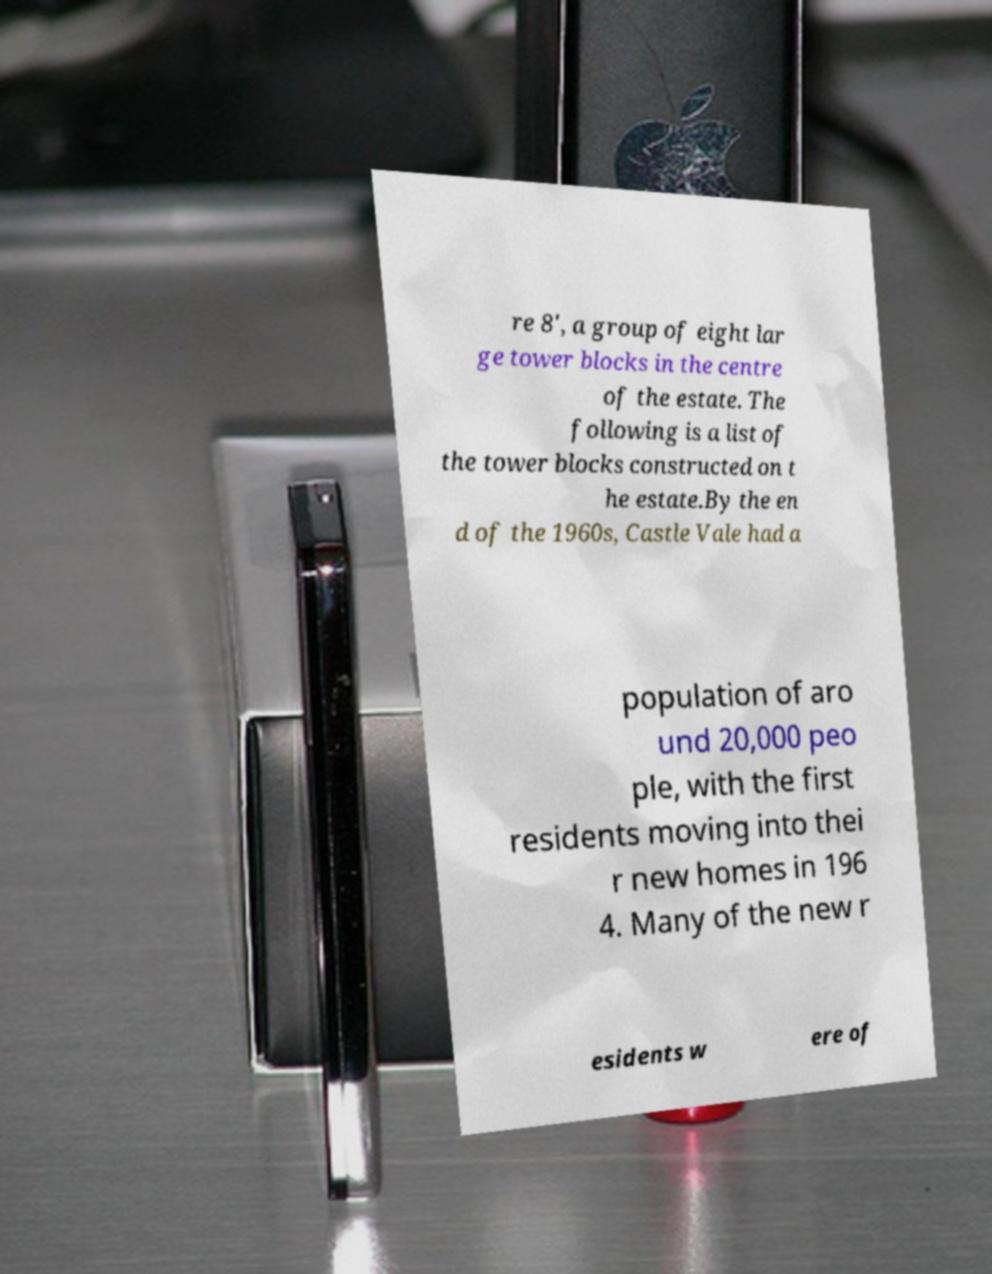I need the written content from this picture converted into text. Can you do that? re 8', a group of eight lar ge tower blocks in the centre of the estate. The following is a list of the tower blocks constructed on t he estate.By the en d of the 1960s, Castle Vale had a population of aro und 20,000 peo ple, with the first residents moving into thei r new homes in 196 4. Many of the new r esidents w ere of 